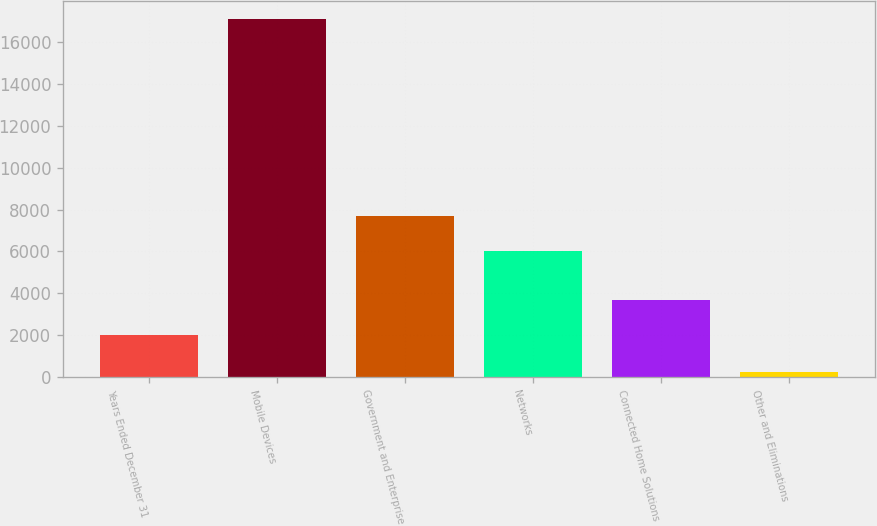Convert chart to OTSL. <chart><loc_0><loc_0><loc_500><loc_500><bar_chart><fcel>Years Ended December 31<fcel>Mobile Devices<fcel>Government and Enterprise<fcel>Networks<fcel>Connected Home Solutions<fcel>Other and Eliminations<nl><fcel>2004<fcel>17108<fcel>7711.5<fcel>6026<fcel>3689.5<fcel>253<nl></chart> 